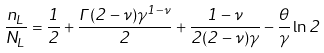Convert formula to latex. <formula><loc_0><loc_0><loc_500><loc_500>\frac { n _ { L } } { N _ { L } } = \frac { 1 } { 2 } + \frac { \Gamma ( 2 - \nu ) \gamma ^ { 1 - \nu } } { 2 } + \frac { 1 - \nu } { 2 ( 2 - \nu ) \gamma } - \frac { \theta } { \gamma } \ln 2</formula> 